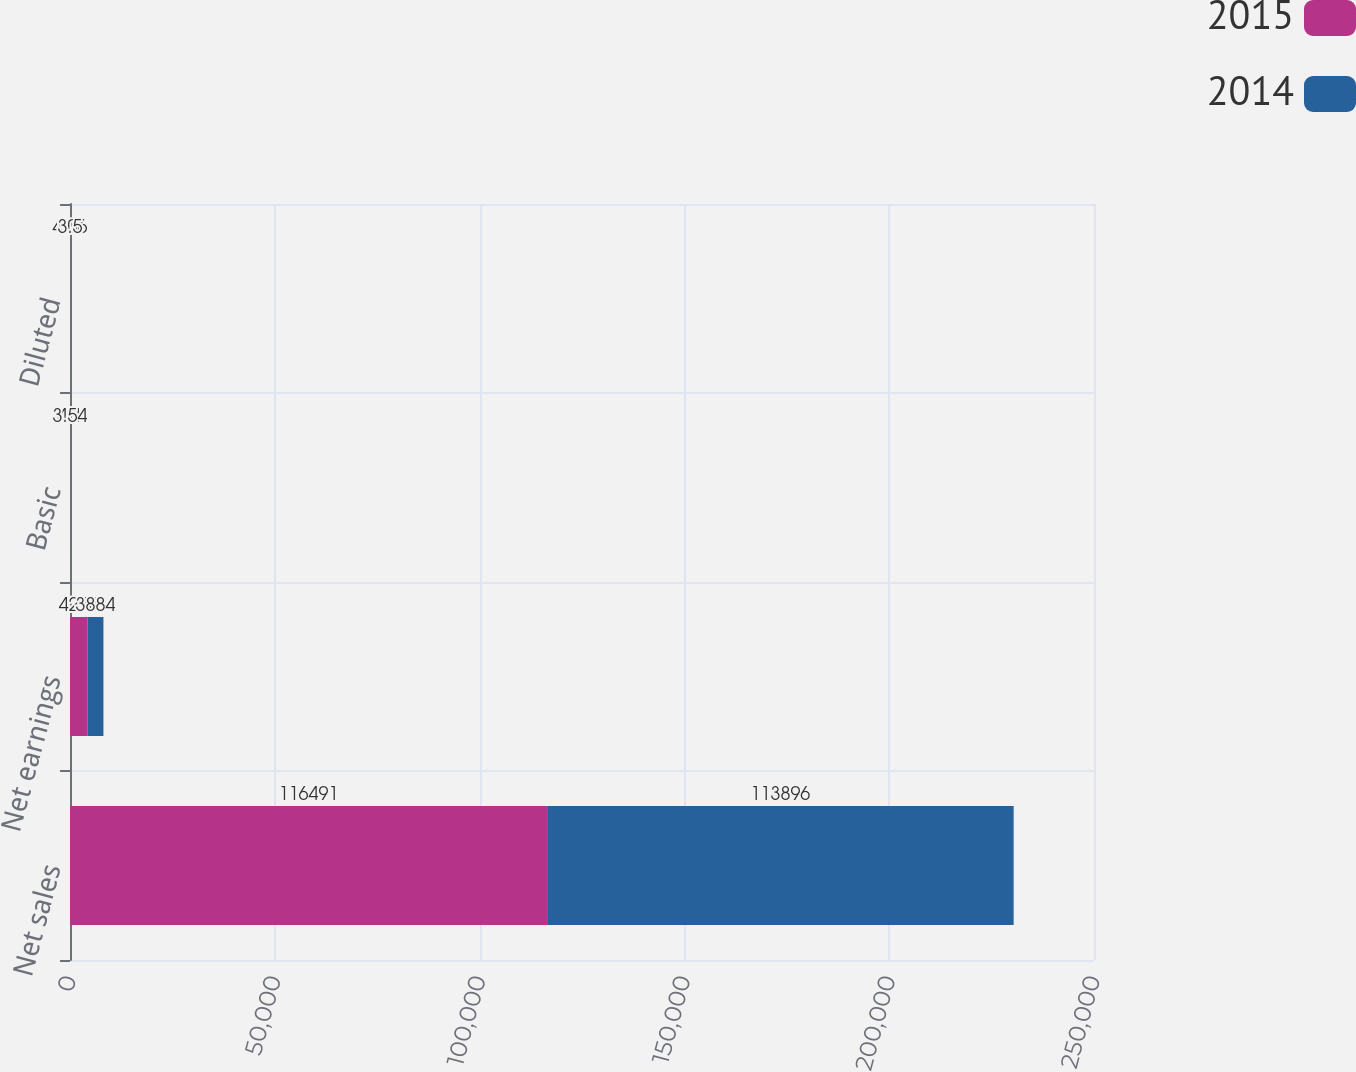<chart> <loc_0><loc_0><loc_500><loc_500><stacked_bar_chart><ecel><fcel>Net sales<fcel>Net earnings<fcel>Basic<fcel>Diluted<nl><fcel>2015<fcel>116491<fcel>4278<fcel>4.1<fcel>4.06<nl><fcel>2014<fcel>113896<fcel>3884<fcel>3.54<fcel>3.5<nl></chart> 